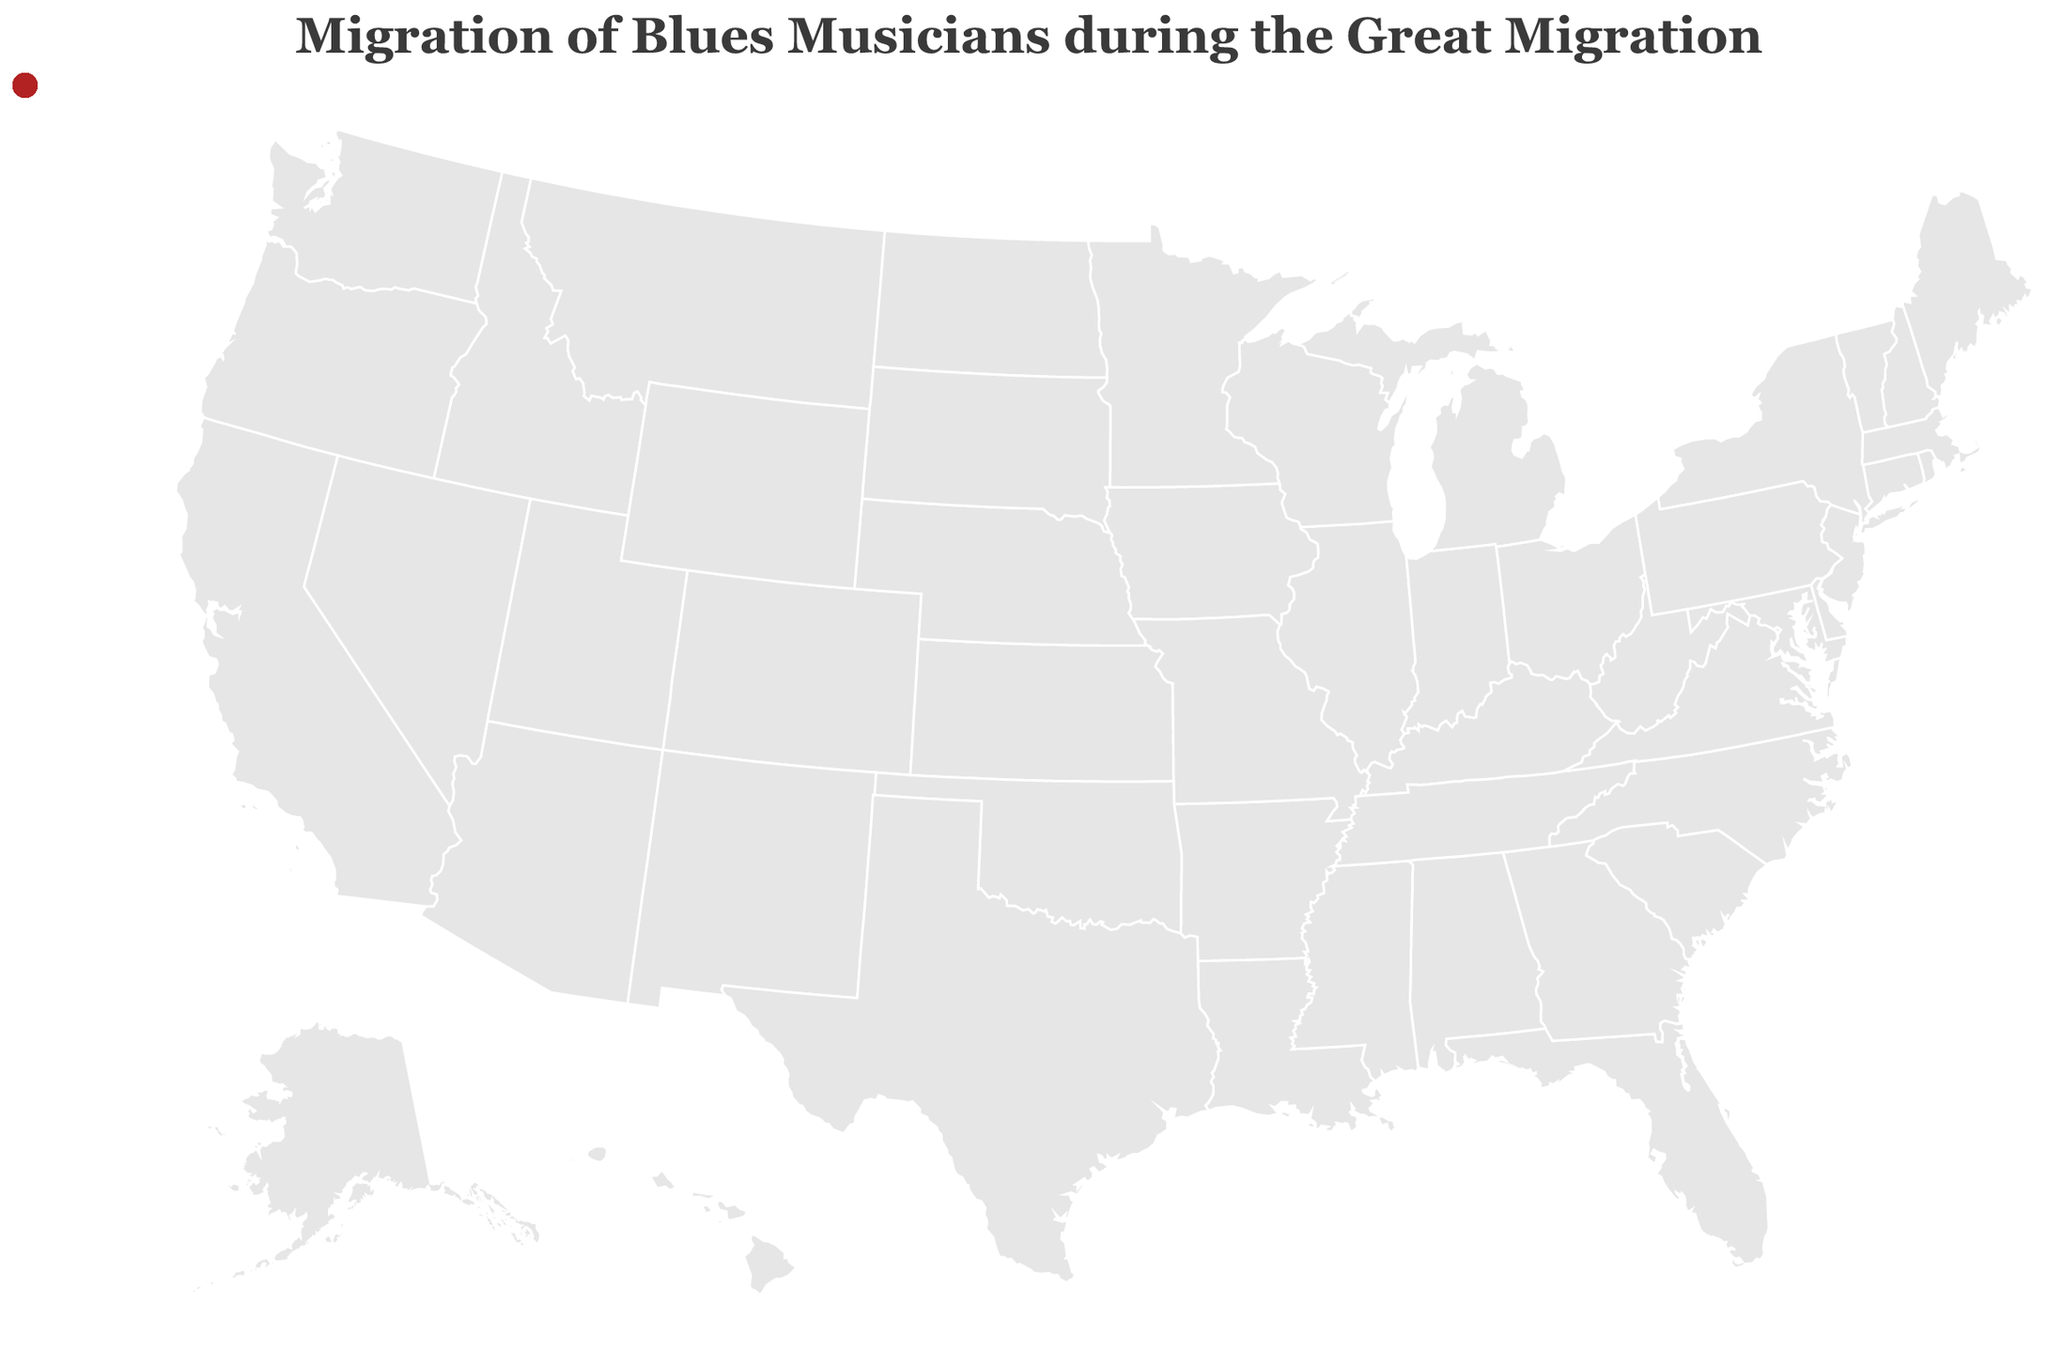Which musician moved to Chicago from New Orleans? The tooltip indicates the musician's name and details about the migration when hovering over the points in New Orleans and Chicago. Earl King moved from New Orleans, LA, to Chicago, IL.
Answer: Earl King How many musicians moved to Chicago during the Great Migration? By looking at the data points on the figure and identifying the number of musicians that show Chicago, IL as the destination, we can count the lines pointing there. They are Earl King, Muddy Waters, Howlin' Wolf, Elmore James, Sonny Boy Williamson II, Little Walter, and Jimmy Reed, amounting to seven.
Answer: 7 Which migration path on the plot has the earliest year of movement? By examining the tooltip details when hovering over all migration paths, we identify the earliest year of movement. Muddy Waters and John Lee Hooker both moved in 1943. Cross-reference their starting points to conclude that John Lee Hooker had the earliest migration path from Clarksdale, MS, to Detroit, MI.
Answer: John Lee Hooker (1943) What is the median year of migration for the musicians? First, we list all the migration years (1943, 1943, 1946, 1945, 1945, 1950, 1952, 1956, 1957, 1948). Arranging them in ascending order gives 1943, 1943, 1945, 1945, 1946, 1948, 1950, 1952, 1956, 1957. The median for an even set of numbers is the average of the two middle values, which are the 5th and 6th values. So, the median is (1946 + 1948) / 2 = 1947.
Answer: 1947 Which destination city received the most musicians during the migration? By counting the number of musician lines terminating at each destination point, we see that Chicago, IL has the most lines (Earl King, Muddy Waters, Howlin' Wolf, Elmore James, Sonny Boy Williamson II, Little Walter, and Jimmy Reed).
Answer: Chicago, IL How did the migratory patterns to Chicago compare to those to Memphis? By identifying the lines leading to each destination city, we observe that 7 musicians migrated to Chicago, while only 1 musician (B.B. King) migrated to Memphis. Therefore, Chicago received significantly more musicians than Memphis during the Great Migration.
Answer: Chicago received more musicians Which original location in Mississippi had the most musicians migrating out? Glancing at the plotted origins, we see multiple departure points from Mississippi. Locations like Issaquena County, Itta Bena, West Point, Clarksdale, Richland, Indianola, Glendora, and Dunleith are marked. By comparing numbers, we identify that each location had 1 musician moving out, so no single location stands out as having the most.
Answer: Each had 1 What is the average time span of migration from origin to destination across all musicians? Listing the years that each migration occurred gives the sequence: 1957, 1943, 1946, 1952, 1943, 1950, 1956, 1945, 1945, 1948. Summing these years gives 1949.8 if divided by 10 (sum: 19498). This represents a conceptual average measure, not a literal time span calculation.
Answer: 1949.8 